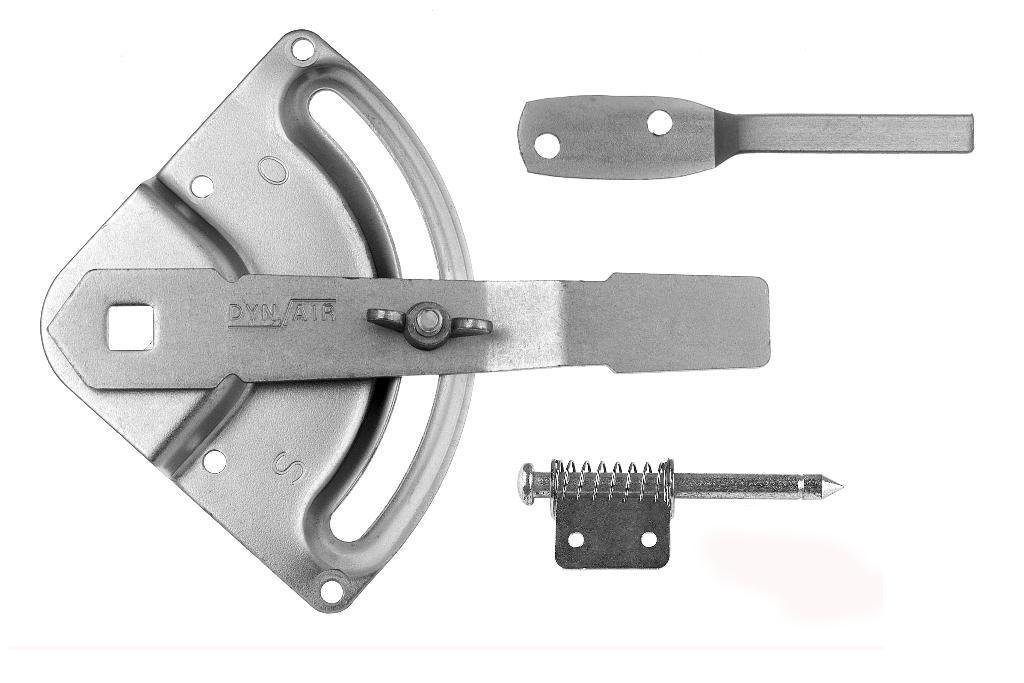Could you give a brief overview of what you see in this image? It is the picture of a part of an air compressor. 